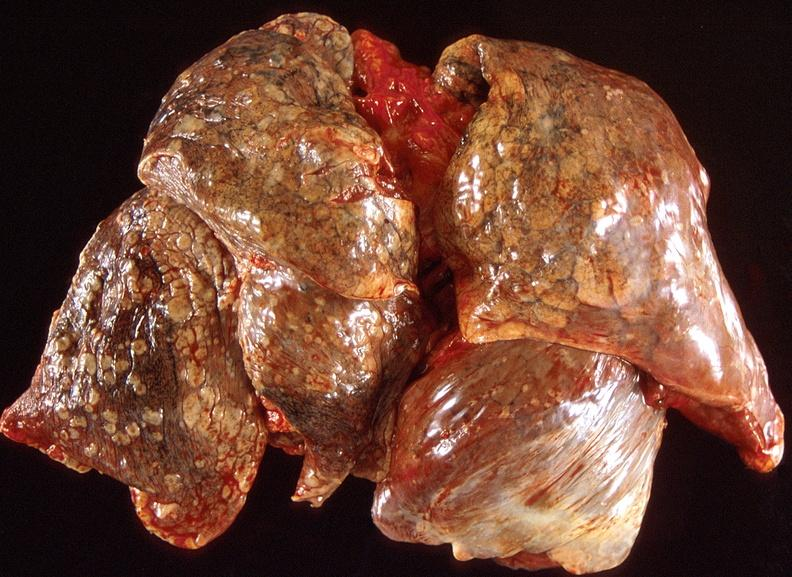s respiratory present?
Answer the question using a single word or phrase. Yes 